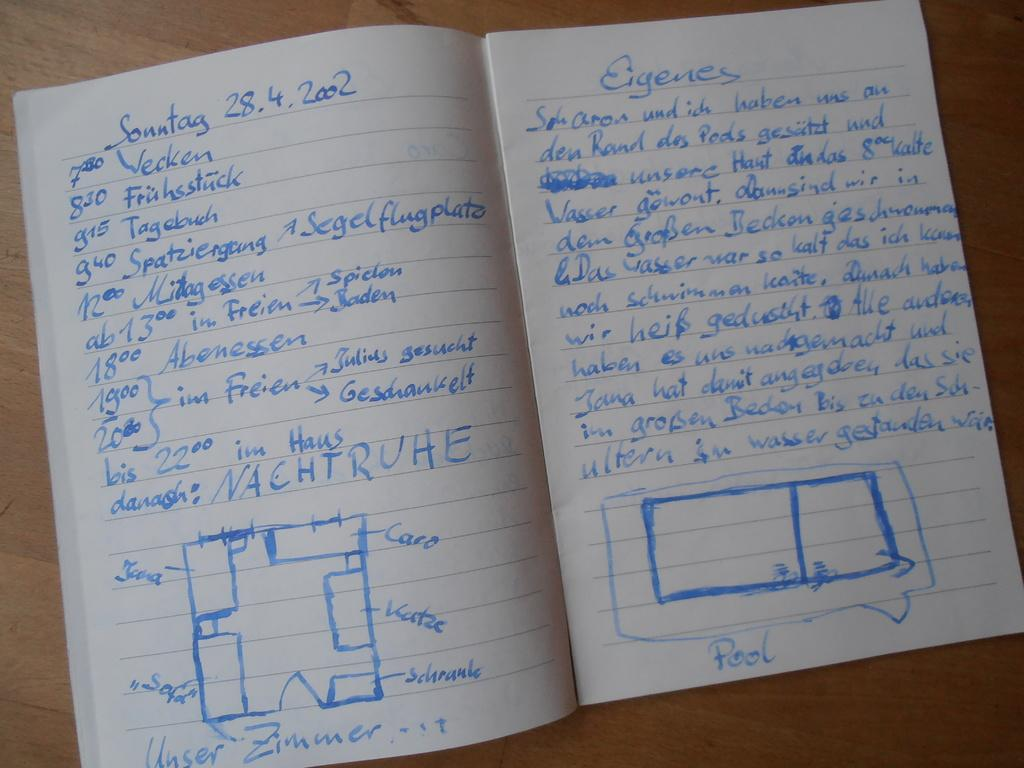Provide a one-sentence caption for the provided image. An open notebook with text written in blue ink from Sonntag 28.4.2002. 